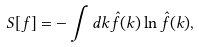<formula> <loc_0><loc_0><loc_500><loc_500>S [ f ] = - \int d k \hat { f } ( k ) \ln \hat { f } ( k ) ,</formula> 